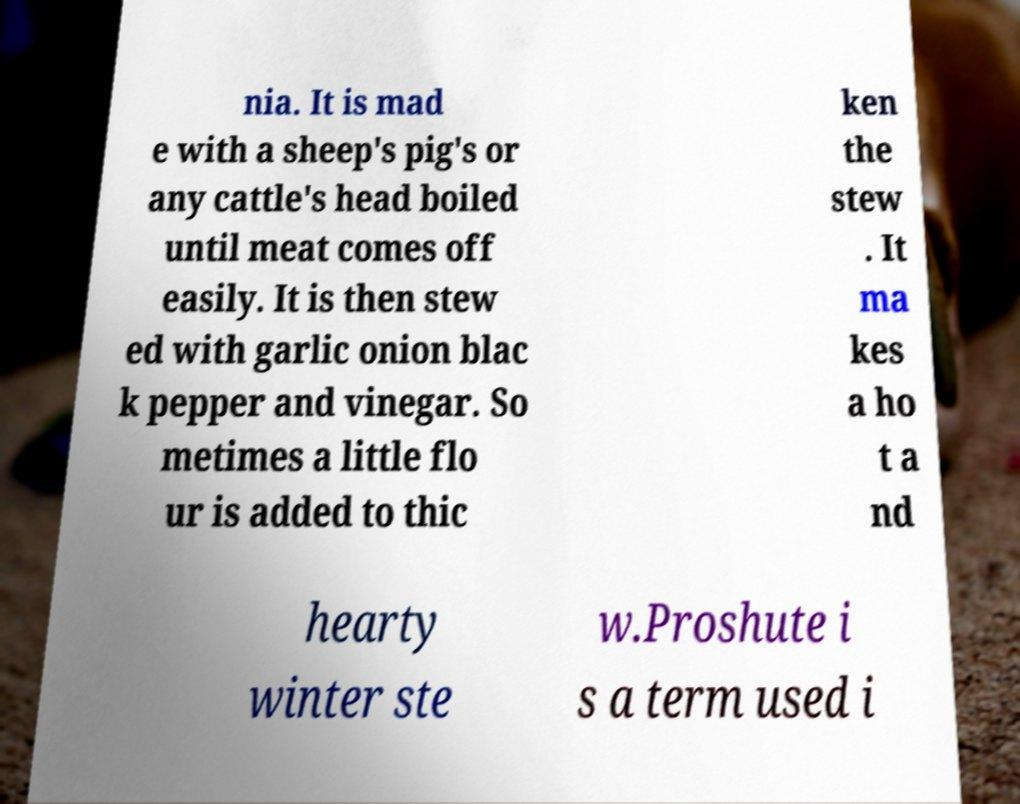Could you extract and type out the text from this image? nia. It is mad e with a sheep's pig's or any cattle's head boiled until meat comes off easily. It is then stew ed with garlic onion blac k pepper and vinegar. So metimes a little flo ur is added to thic ken the stew . It ma kes a ho t a nd hearty winter ste w.Proshute i s a term used i 